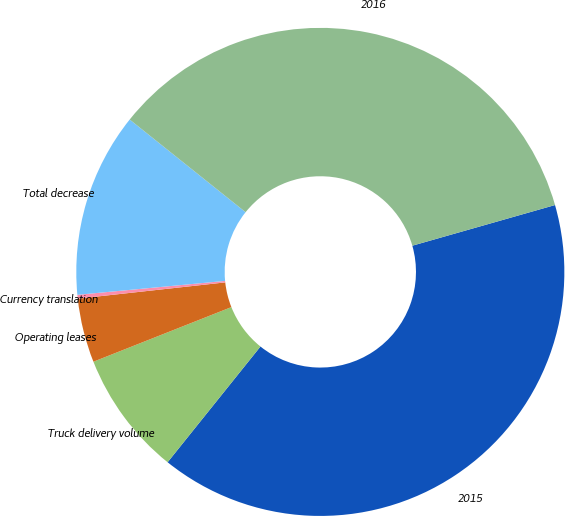Convert chart. <chart><loc_0><loc_0><loc_500><loc_500><pie_chart><fcel>2015<fcel>Truck delivery volume<fcel>Operating leases<fcel>Currency translation<fcel>Total decrease<fcel>2016<nl><fcel>40.18%<fcel>8.24%<fcel>4.25%<fcel>0.25%<fcel>12.23%<fcel>34.85%<nl></chart> 